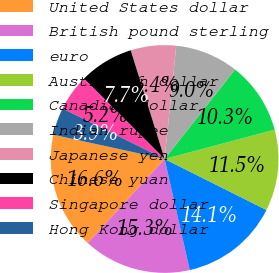Convert chart to OTSL. <chart><loc_0><loc_0><loc_500><loc_500><pie_chart><fcel>United States dollar<fcel>British pound sterling<fcel>euro<fcel>Australian dollar<fcel>Canadian dollar<fcel>Indian rupee<fcel>Japanese yen<fcel>Chinese yuan<fcel>Singapore dollar<fcel>Hong Kong dollar<nl><fcel>16.62%<fcel>15.34%<fcel>14.07%<fcel>11.53%<fcel>10.25%<fcel>8.98%<fcel>6.44%<fcel>7.71%<fcel>5.17%<fcel>3.89%<nl></chart> 